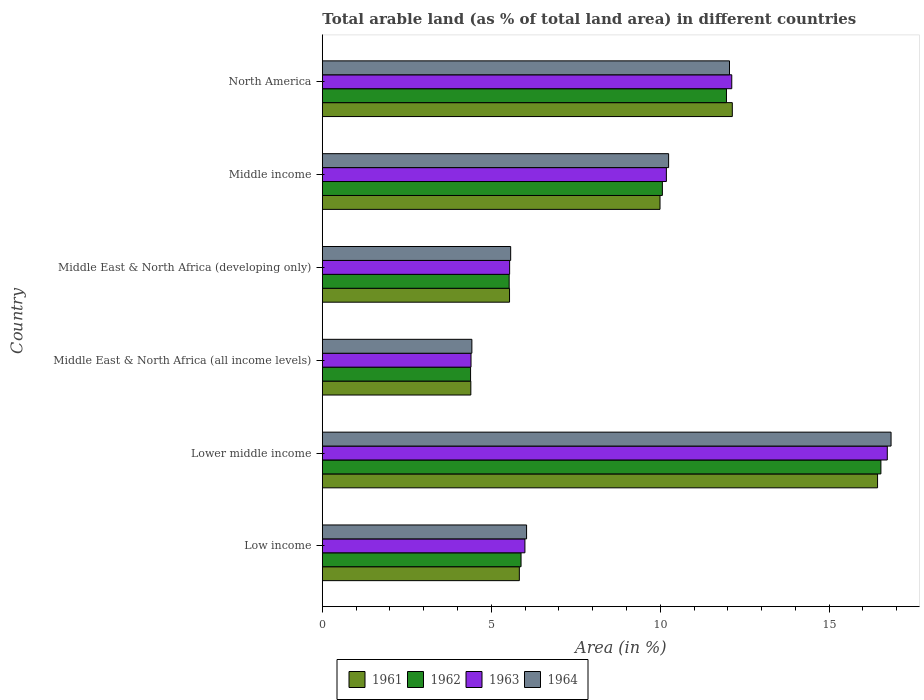Are the number of bars per tick equal to the number of legend labels?
Keep it short and to the point. Yes. Are the number of bars on each tick of the Y-axis equal?
Your answer should be very brief. Yes. How many bars are there on the 3rd tick from the top?
Your answer should be very brief. 4. How many bars are there on the 2nd tick from the bottom?
Offer a very short reply. 4. What is the percentage of arable land in 1961 in Middle income?
Your response must be concise. 9.99. Across all countries, what is the maximum percentage of arable land in 1961?
Give a very brief answer. 16.43. Across all countries, what is the minimum percentage of arable land in 1961?
Your answer should be compact. 4.4. In which country was the percentage of arable land in 1962 maximum?
Offer a very short reply. Lower middle income. In which country was the percentage of arable land in 1962 minimum?
Keep it short and to the point. Middle East & North Africa (all income levels). What is the total percentage of arable land in 1961 in the graph?
Your answer should be very brief. 54.33. What is the difference between the percentage of arable land in 1962 in Lower middle income and that in North America?
Your answer should be compact. 4.57. What is the difference between the percentage of arable land in 1962 in Middle income and the percentage of arable land in 1961 in Middle East & North Africa (developing only)?
Ensure brevity in your answer.  4.52. What is the average percentage of arable land in 1964 per country?
Keep it short and to the point. 9.2. What is the difference between the percentage of arable land in 1962 and percentage of arable land in 1961 in Middle income?
Keep it short and to the point. 0.07. In how many countries, is the percentage of arable land in 1963 greater than 8 %?
Keep it short and to the point. 3. What is the ratio of the percentage of arable land in 1964 in Middle East & North Africa (developing only) to that in North America?
Your response must be concise. 0.46. Is the percentage of arable land in 1963 in Lower middle income less than that in North America?
Offer a very short reply. No. Is the difference between the percentage of arable land in 1962 in Low income and North America greater than the difference between the percentage of arable land in 1961 in Low income and North America?
Provide a succinct answer. Yes. What is the difference between the highest and the second highest percentage of arable land in 1963?
Offer a terse response. 4.6. What is the difference between the highest and the lowest percentage of arable land in 1964?
Ensure brevity in your answer.  12.41. In how many countries, is the percentage of arable land in 1964 greater than the average percentage of arable land in 1964 taken over all countries?
Offer a very short reply. 3. Is it the case that in every country, the sum of the percentage of arable land in 1964 and percentage of arable land in 1961 is greater than the sum of percentage of arable land in 1962 and percentage of arable land in 1963?
Make the answer very short. No. What does the 4th bar from the bottom in Low income represents?
Offer a terse response. 1964. Is it the case that in every country, the sum of the percentage of arable land in 1964 and percentage of arable land in 1961 is greater than the percentage of arable land in 1963?
Provide a short and direct response. Yes. Are all the bars in the graph horizontal?
Make the answer very short. Yes. How many countries are there in the graph?
Make the answer very short. 6. What is the difference between two consecutive major ticks on the X-axis?
Offer a terse response. 5. Are the values on the major ticks of X-axis written in scientific E-notation?
Give a very brief answer. No. Does the graph contain any zero values?
Your answer should be compact. No. How many legend labels are there?
Provide a succinct answer. 4. What is the title of the graph?
Offer a very short reply. Total arable land (as % of total land area) in different countries. Does "1974" appear as one of the legend labels in the graph?
Make the answer very short. No. What is the label or title of the X-axis?
Make the answer very short. Area (in %). What is the label or title of the Y-axis?
Offer a terse response. Country. What is the Area (in %) of 1961 in Low income?
Your response must be concise. 5.83. What is the Area (in %) of 1962 in Low income?
Your answer should be very brief. 5.88. What is the Area (in %) of 1963 in Low income?
Offer a terse response. 6. What is the Area (in %) of 1964 in Low income?
Provide a short and direct response. 6.04. What is the Area (in %) of 1961 in Lower middle income?
Your answer should be very brief. 16.43. What is the Area (in %) of 1962 in Lower middle income?
Offer a very short reply. 16.53. What is the Area (in %) in 1963 in Lower middle income?
Ensure brevity in your answer.  16.72. What is the Area (in %) in 1964 in Lower middle income?
Your answer should be compact. 16.83. What is the Area (in %) in 1961 in Middle East & North Africa (all income levels)?
Ensure brevity in your answer.  4.4. What is the Area (in %) of 1962 in Middle East & North Africa (all income levels)?
Offer a very short reply. 4.39. What is the Area (in %) in 1963 in Middle East & North Africa (all income levels)?
Give a very brief answer. 4.4. What is the Area (in %) of 1964 in Middle East & North Africa (all income levels)?
Offer a terse response. 4.43. What is the Area (in %) in 1961 in Middle East & North Africa (developing only)?
Your answer should be very brief. 5.54. What is the Area (in %) of 1962 in Middle East & North Africa (developing only)?
Keep it short and to the point. 5.53. What is the Area (in %) of 1963 in Middle East & North Africa (developing only)?
Ensure brevity in your answer.  5.54. What is the Area (in %) of 1964 in Middle East & North Africa (developing only)?
Offer a very short reply. 5.57. What is the Area (in %) of 1961 in Middle income?
Offer a terse response. 9.99. What is the Area (in %) of 1962 in Middle income?
Offer a very short reply. 10.06. What is the Area (in %) in 1963 in Middle income?
Offer a very short reply. 10.18. What is the Area (in %) of 1964 in Middle income?
Give a very brief answer. 10.25. What is the Area (in %) in 1961 in North America?
Your answer should be compact. 12.13. What is the Area (in %) in 1962 in North America?
Your answer should be compact. 11.96. What is the Area (in %) in 1963 in North America?
Provide a short and direct response. 12.12. What is the Area (in %) of 1964 in North America?
Provide a succinct answer. 12.05. Across all countries, what is the maximum Area (in %) of 1961?
Your response must be concise. 16.43. Across all countries, what is the maximum Area (in %) of 1962?
Offer a very short reply. 16.53. Across all countries, what is the maximum Area (in %) of 1963?
Your answer should be compact. 16.72. Across all countries, what is the maximum Area (in %) of 1964?
Keep it short and to the point. 16.83. Across all countries, what is the minimum Area (in %) of 1961?
Give a very brief answer. 4.4. Across all countries, what is the minimum Area (in %) in 1962?
Your answer should be very brief. 4.39. Across all countries, what is the minimum Area (in %) of 1963?
Make the answer very short. 4.4. Across all countries, what is the minimum Area (in %) in 1964?
Offer a very short reply. 4.43. What is the total Area (in %) in 1961 in the graph?
Provide a short and direct response. 54.33. What is the total Area (in %) of 1962 in the graph?
Your answer should be compact. 54.35. What is the total Area (in %) in 1963 in the graph?
Your answer should be very brief. 54.96. What is the total Area (in %) of 1964 in the graph?
Provide a short and direct response. 55.18. What is the difference between the Area (in %) of 1961 in Low income and that in Lower middle income?
Ensure brevity in your answer.  -10.6. What is the difference between the Area (in %) of 1962 in Low income and that in Lower middle income?
Your answer should be very brief. -10.65. What is the difference between the Area (in %) in 1963 in Low income and that in Lower middle income?
Offer a terse response. -10.72. What is the difference between the Area (in %) of 1964 in Low income and that in Lower middle income?
Provide a short and direct response. -10.79. What is the difference between the Area (in %) of 1961 in Low income and that in Middle East & North Africa (all income levels)?
Keep it short and to the point. 1.44. What is the difference between the Area (in %) of 1962 in Low income and that in Middle East & North Africa (all income levels)?
Your response must be concise. 1.49. What is the difference between the Area (in %) of 1963 in Low income and that in Middle East & North Africa (all income levels)?
Make the answer very short. 1.6. What is the difference between the Area (in %) of 1964 in Low income and that in Middle East & North Africa (all income levels)?
Give a very brief answer. 1.62. What is the difference between the Area (in %) in 1961 in Low income and that in Middle East & North Africa (developing only)?
Keep it short and to the point. 0.29. What is the difference between the Area (in %) of 1962 in Low income and that in Middle East & North Africa (developing only)?
Your answer should be compact. 0.35. What is the difference between the Area (in %) in 1963 in Low income and that in Middle East & North Africa (developing only)?
Provide a succinct answer. 0.45. What is the difference between the Area (in %) in 1964 in Low income and that in Middle East & North Africa (developing only)?
Provide a short and direct response. 0.47. What is the difference between the Area (in %) in 1961 in Low income and that in Middle income?
Offer a very short reply. -4.16. What is the difference between the Area (in %) of 1962 in Low income and that in Middle income?
Offer a terse response. -4.18. What is the difference between the Area (in %) of 1963 in Low income and that in Middle income?
Provide a succinct answer. -4.19. What is the difference between the Area (in %) of 1964 in Low income and that in Middle income?
Provide a succinct answer. -4.2. What is the difference between the Area (in %) of 1961 in Low income and that in North America?
Make the answer very short. -6.3. What is the difference between the Area (in %) in 1962 in Low income and that in North America?
Offer a very short reply. -6.08. What is the difference between the Area (in %) of 1963 in Low income and that in North America?
Your answer should be compact. -6.12. What is the difference between the Area (in %) in 1964 in Low income and that in North America?
Keep it short and to the point. -6.01. What is the difference between the Area (in %) of 1961 in Lower middle income and that in Middle East & North Africa (all income levels)?
Your response must be concise. 12.04. What is the difference between the Area (in %) of 1962 in Lower middle income and that in Middle East & North Africa (all income levels)?
Your response must be concise. 12.14. What is the difference between the Area (in %) of 1963 in Lower middle income and that in Middle East & North Africa (all income levels)?
Offer a very short reply. 12.32. What is the difference between the Area (in %) in 1964 in Lower middle income and that in Middle East & North Africa (all income levels)?
Provide a succinct answer. 12.41. What is the difference between the Area (in %) in 1961 in Lower middle income and that in Middle East & North Africa (developing only)?
Your answer should be compact. 10.89. What is the difference between the Area (in %) in 1962 in Lower middle income and that in Middle East & North Africa (developing only)?
Ensure brevity in your answer.  11. What is the difference between the Area (in %) in 1963 in Lower middle income and that in Middle East & North Africa (developing only)?
Make the answer very short. 11.18. What is the difference between the Area (in %) of 1964 in Lower middle income and that in Middle East & North Africa (developing only)?
Your answer should be very brief. 11.26. What is the difference between the Area (in %) in 1961 in Lower middle income and that in Middle income?
Your response must be concise. 6.44. What is the difference between the Area (in %) in 1962 in Lower middle income and that in Middle income?
Ensure brevity in your answer.  6.47. What is the difference between the Area (in %) in 1963 in Lower middle income and that in Middle income?
Make the answer very short. 6.54. What is the difference between the Area (in %) in 1964 in Lower middle income and that in Middle income?
Offer a very short reply. 6.58. What is the difference between the Area (in %) in 1961 in Lower middle income and that in North America?
Your answer should be compact. 4.3. What is the difference between the Area (in %) of 1962 in Lower middle income and that in North America?
Make the answer very short. 4.57. What is the difference between the Area (in %) in 1963 in Lower middle income and that in North America?
Ensure brevity in your answer.  4.6. What is the difference between the Area (in %) of 1964 in Lower middle income and that in North America?
Your answer should be very brief. 4.78. What is the difference between the Area (in %) of 1961 in Middle East & North Africa (all income levels) and that in Middle East & North Africa (developing only)?
Offer a terse response. -1.15. What is the difference between the Area (in %) in 1962 in Middle East & North Africa (all income levels) and that in Middle East & North Africa (developing only)?
Offer a terse response. -1.14. What is the difference between the Area (in %) of 1963 in Middle East & North Africa (all income levels) and that in Middle East & North Africa (developing only)?
Make the answer very short. -1.14. What is the difference between the Area (in %) in 1964 in Middle East & North Africa (all income levels) and that in Middle East & North Africa (developing only)?
Your answer should be compact. -1.15. What is the difference between the Area (in %) in 1961 in Middle East & North Africa (all income levels) and that in Middle income?
Make the answer very short. -5.6. What is the difference between the Area (in %) of 1962 in Middle East & North Africa (all income levels) and that in Middle income?
Provide a succinct answer. -5.68. What is the difference between the Area (in %) of 1963 in Middle East & North Africa (all income levels) and that in Middle income?
Your response must be concise. -5.78. What is the difference between the Area (in %) in 1964 in Middle East & North Africa (all income levels) and that in Middle income?
Ensure brevity in your answer.  -5.82. What is the difference between the Area (in %) in 1961 in Middle East & North Africa (all income levels) and that in North America?
Offer a very short reply. -7.74. What is the difference between the Area (in %) of 1962 in Middle East & North Africa (all income levels) and that in North America?
Offer a very short reply. -7.57. What is the difference between the Area (in %) in 1963 in Middle East & North Africa (all income levels) and that in North America?
Your answer should be very brief. -7.72. What is the difference between the Area (in %) of 1964 in Middle East & North Africa (all income levels) and that in North America?
Offer a terse response. -7.62. What is the difference between the Area (in %) in 1961 in Middle East & North Africa (developing only) and that in Middle income?
Provide a succinct answer. -4.45. What is the difference between the Area (in %) of 1962 in Middle East & North Africa (developing only) and that in Middle income?
Provide a succinct answer. -4.53. What is the difference between the Area (in %) of 1963 in Middle East & North Africa (developing only) and that in Middle income?
Keep it short and to the point. -4.64. What is the difference between the Area (in %) of 1964 in Middle East & North Africa (developing only) and that in Middle income?
Your response must be concise. -4.67. What is the difference between the Area (in %) of 1961 in Middle East & North Africa (developing only) and that in North America?
Your response must be concise. -6.59. What is the difference between the Area (in %) in 1962 in Middle East & North Africa (developing only) and that in North America?
Provide a succinct answer. -6.43. What is the difference between the Area (in %) in 1963 in Middle East & North Africa (developing only) and that in North America?
Offer a very short reply. -6.57. What is the difference between the Area (in %) in 1964 in Middle East & North Africa (developing only) and that in North America?
Make the answer very short. -6.48. What is the difference between the Area (in %) in 1961 in Middle income and that in North America?
Your answer should be compact. -2.14. What is the difference between the Area (in %) in 1962 in Middle income and that in North America?
Your response must be concise. -1.9. What is the difference between the Area (in %) in 1963 in Middle income and that in North America?
Provide a succinct answer. -1.94. What is the difference between the Area (in %) in 1964 in Middle income and that in North America?
Provide a short and direct response. -1.8. What is the difference between the Area (in %) of 1961 in Low income and the Area (in %) of 1962 in Lower middle income?
Your answer should be compact. -10.7. What is the difference between the Area (in %) of 1961 in Low income and the Area (in %) of 1963 in Lower middle income?
Your answer should be compact. -10.89. What is the difference between the Area (in %) of 1961 in Low income and the Area (in %) of 1964 in Lower middle income?
Keep it short and to the point. -11. What is the difference between the Area (in %) in 1962 in Low income and the Area (in %) in 1963 in Lower middle income?
Your answer should be compact. -10.84. What is the difference between the Area (in %) in 1962 in Low income and the Area (in %) in 1964 in Lower middle income?
Keep it short and to the point. -10.95. What is the difference between the Area (in %) of 1963 in Low income and the Area (in %) of 1964 in Lower middle income?
Offer a terse response. -10.84. What is the difference between the Area (in %) in 1961 in Low income and the Area (in %) in 1962 in Middle East & North Africa (all income levels)?
Offer a very short reply. 1.44. What is the difference between the Area (in %) of 1961 in Low income and the Area (in %) of 1963 in Middle East & North Africa (all income levels)?
Make the answer very short. 1.43. What is the difference between the Area (in %) in 1961 in Low income and the Area (in %) in 1964 in Middle East & North Africa (all income levels)?
Offer a very short reply. 1.4. What is the difference between the Area (in %) of 1962 in Low income and the Area (in %) of 1963 in Middle East & North Africa (all income levels)?
Provide a succinct answer. 1.48. What is the difference between the Area (in %) of 1962 in Low income and the Area (in %) of 1964 in Middle East & North Africa (all income levels)?
Ensure brevity in your answer.  1.46. What is the difference between the Area (in %) in 1963 in Low income and the Area (in %) in 1964 in Middle East & North Africa (all income levels)?
Keep it short and to the point. 1.57. What is the difference between the Area (in %) of 1961 in Low income and the Area (in %) of 1962 in Middle East & North Africa (developing only)?
Ensure brevity in your answer.  0.3. What is the difference between the Area (in %) of 1961 in Low income and the Area (in %) of 1963 in Middle East & North Africa (developing only)?
Provide a short and direct response. 0.29. What is the difference between the Area (in %) in 1961 in Low income and the Area (in %) in 1964 in Middle East & North Africa (developing only)?
Keep it short and to the point. 0.26. What is the difference between the Area (in %) of 1962 in Low income and the Area (in %) of 1963 in Middle East & North Africa (developing only)?
Your response must be concise. 0.34. What is the difference between the Area (in %) in 1962 in Low income and the Area (in %) in 1964 in Middle East & North Africa (developing only)?
Your answer should be very brief. 0.31. What is the difference between the Area (in %) of 1963 in Low income and the Area (in %) of 1964 in Middle East & North Africa (developing only)?
Give a very brief answer. 0.42. What is the difference between the Area (in %) of 1961 in Low income and the Area (in %) of 1962 in Middle income?
Make the answer very short. -4.23. What is the difference between the Area (in %) of 1961 in Low income and the Area (in %) of 1963 in Middle income?
Your answer should be compact. -4.35. What is the difference between the Area (in %) in 1961 in Low income and the Area (in %) in 1964 in Middle income?
Offer a terse response. -4.42. What is the difference between the Area (in %) of 1962 in Low income and the Area (in %) of 1963 in Middle income?
Ensure brevity in your answer.  -4.3. What is the difference between the Area (in %) in 1962 in Low income and the Area (in %) in 1964 in Middle income?
Offer a very short reply. -4.37. What is the difference between the Area (in %) in 1963 in Low income and the Area (in %) in 1964 in Middle income?
Keep it short and to the point. -4.25. What is the difference between the Area (in %) in 1961 in Low income and the Area (in %) in 1962 in North America?
Your response must be concise. -6.13. What is the difference between the Area (in %) in 1961 in Low income and the Area (in %) in 1963 in North America?
Provide a short and direct response. -6.29. What is the difference between the Area (in %) of 1961 in Low income and the Area (in %) of 1964 in North America?
Provide a succinct answer. -6.22. What is the difference between the Area (in %) in 1962 in Low income and the Area (in %) in 1963 in North America?
Your response must be concise. -6.24. What is the difference between the Area (in %) in 1962 in Low income and the Area (in %) in 1964 in North America?
Ensure brevity in your answer.  -6.17. What is the difference between the Area (in %) of 1963 in Low income and the Area (in %) of 1964 in North America?
Your response must be concise. -6.05. What is the difference between the Area (in %) in 1961 in Lower middle income and the Area (in %) in 1962 in Middle East & North Africa (all income levels)?
Ensure brevity in your answer.  12.04. What is the difference between the Area (in %) of 1961 in Lower middle income and the Area (in %) of 1963 in Middle East & North Africa (all income levels)?
Provide a succinct answer. 12.03. What is the difference between the Area (in %) in 1961 in Lower middle income and the Area (in %) in 1964 in Middle East & North Africa (all income levels)?
Your answer should be compact. 12.01. What is the difference between the Area (in %) in 1962 in Lower middle income and the Area (in %) in 1963 in Middle East & North Africa (all income levels)?
Offer a very short reply. 12.13. What is the difference between the Area (in %) in 1962 in Lower middle income and the Area (in %) in 1964 in Middle East & North Africa (all income levels)?
Ensure brevity in your answer.  12.11. What is the difference between the Area (in %) in 1963 in Lower middle income and the Area (in %) in 1964 in Middle East & North Africa (all income levels)?
Your answer should be very brief. 12.29. What is the difference between the Area (in %) of 1961 in Lower middle income and the Area (in %) of 1962 in Middle East & North Africa (developing only)?
Provide a succinct answer. 10.9. What is the difference between the Area (in %) in 1961 in Lower middle income and the Area (in %) in 1963 in Middle East & North Africa (developing only)?
Make the answer very short. 10.89. What is the difference between the Area (in %) of 1961 in Lower middle income and the Area (in %) of 1964 in Middle East & North Africa (developing only)?
Your answer should be very brief. 10.86. What is the difference between the Area (in %) in 1962 in Lower middle income and the Area (in %) in 1963 in Middle East & North Africa (developing only)?
Provide a succinct answer. 10.99. What is the difference between the Area (in %) in 1962 in Lower middle income and the Area (in %) in 1964 in Middle East & North Africa (developing only)?
Provide a succinct answer. 10.96. What is the difference between the Area (in %) of 1963 in Lower middle income and the Area (in %) of 1964 in Middle East & North Africa (developing only)?
Offer a very short reply. 11.15. What is the difference between the Area (in %) of 1961 in Lower middle income and the Area (in %) of 1962 in Middle income?
Ensure brevity in your answer.  6.37. What is the difference between the Area (in %) in 1961 in Lower middle income and the Area (in %) in 1963 in Middle income?
Your answer should be compact. 6.25. What is the difference between the Area (in %) of 1961 in Lower middle income and the Area (in %) of 1964 in Middle income?
Offer a terse response. 6.18. What is the difference between the Area (in %) of 1962 in Lower middle income and the Area (in %) of 1963 in Middle income?
Your answer should be very brief. 6.35. What is the difference between the Area (in %) in 1962 in Lower middle income and the Area (in %) in 1964 in Middle income?
Provide a succinct answer. 6.28. What is the difference between the Area (in %) of 1963 in Lower middle income and the Area (in %) of 1964 in Middle income?
Offer a terse response. 6.47. What is the difference between the Area (in %) in 1961 in Lower middle income and the Area (in %) in 1962 in North America?
Your answer should be compact. 4.47. What is the difference between the Area (in %) in 1961 in Lower middle income and the Area (in %) in 1963 in North America?
Provide a succinct answer. 4.32. What is the difference between the Area (in %) of 1961 in Lower middle income and the Area (in %) of 1964 in North America?
Give a very brief answer. 4.38. What is the difference between the Area (in %) in 1962 in Lower middle income and the Area (in %) in 1963 in North America?
Provide a succinct answer. 4.41. What is the difference between the Area (in %) of 1962 in Lower middle income and the Area (in %) of 1964 in North America?
Keep it short and to the point. 4.48. What is the difference between the Area (in %) of 1963 in Lower middle income and the Area (in %) of 1964 in North America?
Your answer should be very brief. 4.67. What is the difference between the Area (in %) of 1961 in Middle East & North Africa (all income levels) and the Area (in %) of 1962 in Middle East & North Africa (developing only)?
Give a very brief answer. -1.13. What is the difference between the Area (in %) of 1961 in Middle East & North Africa (all income levels) and the Area (in %) of 1963 in Middle East & North Africa (developing only)?
Provide a succinct answer. -1.15. What is the difference between the Area (in %) of 1961 in Middle East & North Africa (all income levels) and the Area (in %) of 1964 in Middle East & North Africa (developing only)?
Provide a short and direct response. -1.18. What is the difference between the Area (in %) of 1962 in Middle East & North Africa (all income levels) and the Area (in %) of 1963 in Middle East & North Africa (developing only)?
Offer a very short reply. -1.16. What is the difference between the Area (in %) in 1962 in Middle East & North Africa (all income levels) and the Area (in %) in 1964 in Middle East & North Africa (developing only)?
Offer a terse response. -1.19. What is the difference between the Area (in %) in 1963 in Middle East & North Africa (all income levels) and the Area (in %) in 1964 in Middle East & North Africa (developing only)?
Offer a very short reply. -1.17. What is the difference between the Area (in %) of 1961 in Middle East & North Africa (all income levels) and the Area (in %) of 1962 in Middle income?
Make the answer very short. -5.67. What is the difference between the Area (in %) in 1961 in Middle East & North Africa (all income levels) and the Area (in %) in 1963 in Middle income?
Your answer should be compact. -5.79. What is the difference between the Area (in %) in 1961 in Middle East & North Africa (all income levels) and the Area (in %) in 1964 in Middle income?
Provide a succinct answer. -5.85. What is the difference between the Area (in %) in 1962 in Middle East & North Africa (all income levels) and the Area (in %) in 1963 in Middle income?
Your answer should be very brief. -5.79. What is the difference between the Area (in %) in 1962 in Middle East & North Africa (all income levels) and the Area (in %) in 1964 in Middle income?
Provide a short and direct response. -5.86. What is the difference between the Area (in %) of 1963 in Middle East & North Africa (all income levels) and the Area (in %) of 1964 in Middle income?
Give a very brief answer. -5.85. What is the difference between the Area (in %) in 1961 in Middle East & North Africa (all income levels) and the Area (in %) in 1962 in North America?
Your response must be concise. -7.57. What is the difference between the Area (in %) of 1961 in Middle East & North Africa (all income levels) and the Area (in %) of 1963 in North America?
Keep it short and to the point. -7.72. What is the difference between the Area (in %) in 1961 in Middle East & North Africa (all income levels) and the Area (in %) in 1964 in North America?
Offer a terse response. -7.66. What is the difference between the Area (in %) in 1962 in Middle East & North Africa (all income levels) and the Area (in %) in 1963 in North America?
Make the answer very short. -7.73. What is the difference between the Area (in %) in 1962 in Middle East & North Africa (all income levels) and the Area (in %) in 1964 in North America?
Give a very brief answer. -7.66. What is the difference between the Area (in %) in 1963 in Middle East & North Africa (all income levels) and the Area (in %) in 1964 in North America?
Provide a short and direct response. -7.65. What is the difference between the Area (in %) of 1961 in Middle East & North Africa (developing only) and the Area (in %) of 1962 in Middle income?
Provide a short and direct response. -4.52. What is the difference between the Area (in %) of 1961 in Middle East & North Africa (developing only) and the Area (in %) of 1963 in Middle income?
Your response must be concise. -4.64. What is the difference between the Area (in %) in 1961 in Middle East & North Africa (developing only) and the Area (in %) in 1964 in Middle income?
Offer a very short reply. -4.71. What is the difference between the Area (in %) in 1962 in Middle East & North Africa (developing only) and the Area (in %) in 1963 in Middle income?
Keep it short and to the point. -4.65. What is the difference between the Area (in %) of 1962 in Middle East & North Africa (developing only) and the Area (in %) of 1964 in Middle income?
Your response must be concise. -4.72. What is the difference between the Area (in %) of 1963 in Middle East & North Africa (developing only) and the Area (in %) of 1964 in Middle income?
Give a very brief answer. -4.71. What is the difference between the Area (in %) of 1961 in Middle East & North Africa (developing only) and the Area (in %) of 1962 in North America?
Your response must be concise. -6.42. What is the difference between the Area (in %) of 1961 in Middle East & North Africa (developing only) and the Area (in %) of 1963 in North America?
Keep it short and to the point. -6.58. What is the difference between the Area (in %) in 1961 in Middle East & North Africa (developing only) and the Area (in %) in 1964 in North America?
Give a very brief answer. -6.51. What is the difference between the Area (in %) of 1962 in Middle East & North Africa (developing only) and the Area (in %) of 1963 in North America?
Give a very brief answer. -6.59. What is the difference between the Area (in %) in 1962 in Middle East & North Africa (developing only) and the Area (in %) in 1964 in North America?
Ensure brevity in your answer.  -6.52. What is the difference between the Area (in %) in 1963 in Middle East & North Africa (developing only) and the Area (in %) in 1964 in North America?
Keep it short and to the point. -6.51. What is the difference between the Area (in %) of 1961 in Middle income and the Area (in %) of 1962 in North America?
Make the answer very short. -1.97. What is the difference between the Area (in %) of 1961 in Middle income and the Area (in %) of 1963 in North America?
Your answer should be compact. -2.12. What is the difference between the Area (in %) of 1961 in Middle income and the Area (in %) of 1964 in North America?
Keep it short and to the point. -2.06. What is the difference between the Area (in %) of 1962 in Middle income and the Area (in %) of 1963 in North America?
Provide a succinct answer. -2.05. What is the difference between the Area (in %) of 1962 in Middle income and the Area (in %) of 1964 in North America?
Ensure brevity in your answer.  -1.99. What is the difference between the Area (in %) of 1963 in Middle income and the Area (in %) of 1964 in North America?
Offer a terse response. -1.87. What is the average Area (in %) of 1961 per country?
Make the answer very short. 9.05. What is the average Area (in %) in 1962 per country?
Offer a very short reply. 9.06. What is the average Area (in %) of 1963 per country?
Give a very brief answer. 9.16. What is the average Area (in %) in 1964 per country?
Your response must be concise. 9.2. What is the difference between the Area (in %) of 1961 and Area (in %) of 1962 in Low income?
Offer a very short reply. -0.05. What is the difference between the Area (in %) of 1961 and Area (in %) of 1963 in Low income?
Provide a short and direct response. -0.17. What is the difference between the Area (in %) of 1961 and Area (in %) of 1964 in Low income?
Keep it short and to the point. -0.21. What is the difference between the Area (in %) of 1962 and Area (in %) of 1963 in Low income?
Offer a very short reply. -0.11. What is the difference between the Area (in %) in 1962 and Area (in %) in 1964 in Low income?
Give a very brief answer. -0.16. What is the difference between the Area (in %) in 1963 and Area (in %) in 1964 in Low income?
Make the answer very short. -0.05. What is the difference between the Area (in %) of 1961 and Area (in %) of 1962 in Lower middle income?
Keep it short and to the point. -0.1. What is the difference between the Area (in %) in 1961 and Area (in %) in 1963 in Lower middle income?
Give a very brief answer. -0.29. What is the difference between the Area (in %) of 1961 and Area (in %) of 1964 in Lower middle income?
Offer a very short reply. -0.4. What is the difference between the Area (in %) of 1962 and Area (in %) of 1963 in Lower middle income?
Provide a short and direct response. -0.19. What is the difference between the Area (in %) in 1962 and Area (in %) in 1964 in Lower middle income?
Ensure brevity in your answer.  -0.3. What is the difference between the Area (in %) of 1963 and Area (in %) of 1964 in Lower middle income?
Provide a succinct answer. -0.11. What is the difference between the Area (in %) in 1961 and Area (in %) in 1962 in Middle East & North Africa (all income levels)?
Make the answer very short. 0.01. What is the difference between the Area (in %) in 1961 and Area (in %) in 1963 in Middle East & North Africa (all income levels)?
Give a very brief answer. -0.01. What is the difference between the Area (in %) of 1961 and Area (in %) of 1964 in Middle East & North Africa (all income levels)?
Offer a very short reply. -0.03. What is the difference between the Area (in %) in 1962 and Area (in %) in 1963 in Middle East & North Africa (all income levels)?
Your response must be concise. -0.01. What is the difference between the Area (in %) of 1962 and Area (in %) of 1964 in Middle East & North Africa (all income levels)?
Ensure brevity in your answer.  -0.04. What is the difference between the Area (in %) in 1963 and Area (in %) in 1964 in Middle East & North Africa (all income levels)?
Give a very brief answer. -0.03. What is the difference between the Area (in %) of 1961 and Area (in %) of 1962 in Middle East & North Africa (developing only)?
Keep it short and to the point. 0.01. What is the difference between the Area (in %) of 1961 and Area (in %) of 1963 in Middle East & North Africa (developing only)?
Your answer should be compact. -0. What is the difference between the Area (in %) of 1961 and Area (in %) of 1964 in Middle East & North Africa (developing only)?
Offer a very short reply. -0.03. What is the difference between the Area (in %) in 1962 and Area (in %) in 1963 in Middle East & North Africa (developing only)?
Offer a very short reply. -0.01. What is the difference between the Area (in %) of 1962 and Area (in %) of 1964 in Middle East & North Africa (developing only)?
Your response must be concise. -0.04. What is the difference between the Area (in %) in 1963 and Area (in %) in 1964 in Middle East & North Africa (developing only)?
Make the answer very short. -0.03. What is the difference between the Area (in %) in 1961 and Area (in %) in 1962 in Middle income?
Provide a short and direct response. -0.07. What is the difference between the Area (in %) of 1961 and Area (in %) of 1963 in Middle income?
Give a very brief answer. -0.19. What is the difference between the Area (in %) of 1961 and Area (in %) of 1964 in Middle income?
Offer a very short reply. -0.25. What is the difference between the Area (in %) in 1962 and Area (in %) in 1963 in Middle income?
Your answer should be very brief. -0.12. What is the difference between the Area (in %) of 1962 and Area (in %) of 1964 in Middle income?
Give a very brief answer. -0.18. What is the difference between the Area (in %) in 1963 and Area (in %) in 1964 in Middle income?
Offer a terse response. -0.07. What is the difference between the Area (in %) in 1961 and Area (in %) in 1962 in North America?
Provide a succinct answer. 0.17. What is the difference between the Area (in %) in 1961 and Area (in %) in 1963 in North America?
Make the answer very short. 0.02. What is the difference between the Area (in %) of 1961 and Area (in %) of 1964 in North America?
Keep it short and to the point. 0.08. What is the difference between the Area (in %) in 1962 and Area (in %) in 1963 in North America?
Your answer should be very brief. -0.16. What is the difference between the Area (in %) of 1962 and Area (in %) of 1964 in North America?
Offer a very short reply. -0.09. What is the difference between the Area (in %) of 1963 and Area (in %) of 1964 in North America?
Offer a very short reply. 0.07. What is the ratio of the Area (in %) in 1961 in Low income to that in Lower middle income?
Offer a terse response. 0.35. What is the ratio of the Area (in %) of 1962 in Low income to that in Lower middle income?
Keep it short and to the point. 0.36. What is the ratio of the Area (in %) of 1963 in Low income to that in Lower middle income?
Give a very brief answer. 0.36. What is the ratio of the Area (in %) of 1964 in Low income to that in Lower middle income?
Make the answer very short. 0.36. What is the ratio of the Area (in %) in 1961 in Low income to that in Middle East & North Africa (all income levels)?
Your answer should be very brief. 1.33. What is the ratio of the Area (in %) in 1962 in Low income to that in Middle East & North Africa (all income levels)?
Offer a very short reply. 1.34. What is the ratio of the Area (in %) of 1963 in Low income to that in Middle East & North Africa (all income levels)?
Give a very brief answer. 1.36. What is the ratio of the Area (in %) in 1964 in Low income to that in Middle East & North Africa (all income levels)?
Ensure brevity in your answer.  1.37. What is the ratio of the Area (in %) of 1961 in Low income to that in Middle East & North Africa (developing only)?
Your answer should be compact. 1.05. What is the ratio of the Area (in %) of 1962 in Low income to that in Middle East & North Africa (developing only)?
Keep it short and to the point. 1.06. What is the ratio of the Area (in %) in 1963 in Low income to that in Middle East & North Africa (developing only)?
Ensure brevity in your answer.  1.08. What is the ratio of the Area (in %) of 1964 in Low income to that in Middle East & North Africa (developing only)?
Ensure brevity in your answer.  1.08. What is the ratio of the Area (in %) in 1961 in Low income to that in Middle income?
Ensure brevity in your answer.  0.58. What is the ratio of the Area (in %) of 1962 in Low income to that in Middle income?
Your answer should be very brief. 0.58. What is the ratio of the Area (in %) in 1963 in Low income to that in Middle income?
Make the answer very short. 0.59. What is the ratio of the Area (in %) in 1964 in Low income to that in Middle income?
Offer a very short reply. 0.59. What is the ratio of the Area (in %) of 1961 in Low income to that in North America?
Give a very brief answer. 0.48. What is the ratio of the Area (in %) in 1962 in Low income to that in North America?
Provide a short and direct response. 0.49. What is the ratio of the Area (in %) in 1963 in Low income to that in North America?
Give a very brief answer. 0.49. What is the ratio of the Area (in %) in 1964 in Low income to that in North America?
Ensure brevity in your answer.  0.5. What is the ratio of the Area (in %) of 1961 in Lower middle income to that in Middle East & North Africa (all income levels)?
Your answer should be compact. 3.74. What is the ratio of the Area (in %) in 1962 in Lower middle income to that in Middle East & North Africa (all income levels)?
Provide a short and direct response. 3.77. What is the ratio of the Area (in %) of 1963 in Lower middle income to that in Middle East & North Africa (all income levels)?
Provide a short and direct response. 3.8. What is the ratio of the Area (in %) in 1964 in Lower middle income to that in Middle East & North Africa (all income levels)?
Make the answer very short. 3.8. What is the ratio of the Area (in %) in 1961 in Lower middle income to that in Middle East & North Africa (developing only)?
Your answer should be very brief. 2.97. What is the ratio of the Area (in %) in 1962 in Lower middle income to that in Middle East & North Africa (developing only)?
Offer a very short reply. 2.99. What is the ratio of the Area (in %) of 1963 in Lower middle income to that in Middle East & North Africa (developing only)?
Offer a terse response. 3.02. What is the ratio of the Area (in %) in 1964 in Lower middle income to that in Middle East & North Africa (developing only)?
Make the answer very short. 3.02. What is the ratio of the Area (in %) of 1961 in Lower middle income to that in Middle income?
Keep it short and to the point. 1.64. What is the ratio of the Area (in %) of 1962 in Lower middle income to that in Middle income?
Your answer should be very brief. 1.64. What is the ratio of the Area (in %) of 1963 in Lower middle income to that in Middle income?
Offer a very short reply. 1.64. What is the ratio of the Area (in %) in 1964 in Lower middle income to that in Middle income?
Offer a very short reply. 1.64. What is the ratio of the Area (in %) in 1961 in Lower middle income to that in North America?
Your response must be concise. 1.35. What is the ratio of the Area (in %) of 1962 in Lower middle income to that in North America?
Make the answer very short. 1.38. What is the ratio of the Area (in %) of 1963 in Lower middle income to that in North America?
Provide a succinct answer. 1.38. What is the ratio of the Area (in %) in 1964 in Lower middle income to that in North America?
Your answer should be compact. 1.4. What is the ratio of the Area (in %) in 1961 in Middle East & North Africa (all income levels) to that in Middle East & North Africa (developing only)?
Give a very brief answer. 0.79. What is the ratio of the Area (in %) of 1962 in Middle East & North Africa (all income levels) to that in Middle East & North Africa (developing only)?
Keep it short and to the point. 0.79. What is the ratio of the Area (in %) of 1963 in Middle East & North Africa (all income levels) to that in Middle East & North Africa (developing only)?
Provide a succinct answer. 0.79. What is the ratio of the Area (in %) in 1964 in Middle East & North Africa (all income levels) to that in Middle East & North Africa (developing only)?
Provide a succinct answer. 0.79. What is the ratio of the Area (in %) of 1961 in Middle East & North Africa (all income levels) to that in Middle income?
Give a very brief answer. 0.44. What is the ratio of the Area (in %) in 1962 in Middle East & North Africa (all income levels) to that in Middle income?
Ensure brevity in your answer.  0.44. What is the ratio of the Area (in %) in 1963 in Middle East & North Africa (all income levels) to that in Middle income?
Your answer should be compact. 0.43. What is the ratio of the Area (in %) of 1964 in Middle East & North Africa (all income levels) to that in Middle income?
Ensure brevity in your answer.  0.43. What is the ratio of the Area (in %) of 1961 in Middle East & North Africa (all income levels) to that in North America?
Offer a terse response. 0.36. What is the ratio of the Area (in %) of 1962 in Middle East & North Africa (all income levels) to that in North America?
Your response must be concise. 0.37. What is the ratio of the Area (in %) of 1963 in Middle East & North Africa (all income levels) to that in North America?
Offer a terse response. 0.36. What is the ratio of the Area (in %) of 1964 in Middle East & North Africa (all income levels) to that in North America?
Your response must be concise. 0.37. What is the ratio of the Area (in %) in 1961 in Middle East & North Africa (developing only) to that in Middle income?
Give a very brief answer. 0.55. What is the ratio of the Area (in %) of 1962 in Middle East & North Africa (developing only) to that in Middle income?
Provide a succinct answer. 0.55. What is the ratio of the Area (in %) in 1963 in Middle East & North Africa (developing only) to that in Middle income?
Provide a short and direct response. 0.54. What is the ratio of the Area (in %) of 1964 in Middle East & North Africa (developing only) to that in Middle income?
Your response must be concise. 0.54. What is the ratio of the Area (in %) of 1961 in Middle East & North Africa (developing only) to that in North America?
Your answer should be compact. 0.46. What is the ratio of the Area (in %) of 1962 in Middle East & North Africa (developing only) to that in North America?
Make the answer very short. 0.46. What is the ratio of the Area (in %) in 1963 in Middle East & North Africa (developing only) to that in North America?
Your answer should be very brief. 0.46. What is the ratio of the Area (in %) in 1964 in Middle East & North Africa (developing only) to that in North America?
Offer a terse response. 0.46. What is the ratio of the Area (in %) in 1961 in Middle income to that in North America?
Your answer should be very brief. 0.82. What is the ratio of the Area (in %) in 1962 in Middle income to that in North America?
Offer a terse response. 0.84. What is the ratio of the Area (in %) of 1963 in Middle income to that in North America?
Ensure brevity in your answer.  0.84. What is the ratio of the Area (in %) in 1964 in Middle income to that in North America?
Offer a terse response. 0.85. What is the difference between the highest and the second highest Area (in %) of 1961?
Keep it short and to the point. 4.3. What is the difference between the highest and the second highest Area (in %) of 1962?
Your answer should be very brief. 4.57. What is the difference between the highest and the second highest Area (in %) of 1963?
Make the answer very short. 4.6. What is the difference between the highest and the second highest Area (in %) in 1964?
Keep it short and to the point. 4.78. What is the difference between the highest and the lowest Area (in %) of 1961?
Your answer should be very brief. 12.04. What is the difference between the highest and the lowest Area (in %) of 1962?
Provide a short and direct response. 12.14. What is the difference between the highest and the lowest Area (in %) of 1963?
Make the answer very short. 12.32. What is the difference between the highest and the lowest Area (in %) in 1964?
Ensure brevity in your answer.  12.41. 